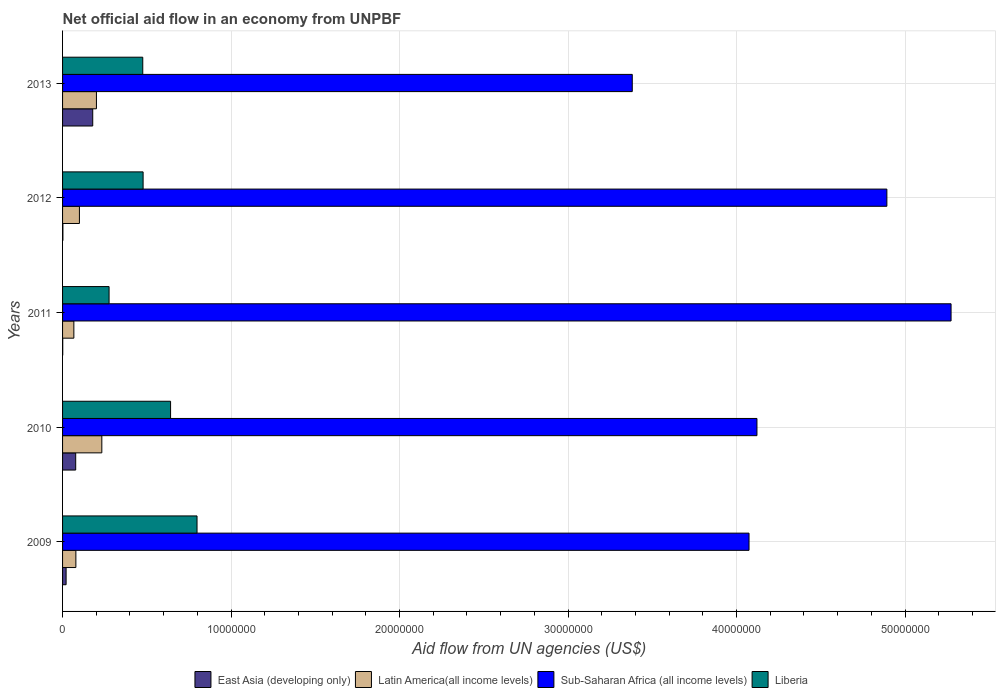How many different coloured bars are there?
Offer a very short reply. 4. How many groups of bars are there?
Your answer should be very brief. 5. Are the number of bars on each tick of the Y-axis equal?
Provide a succinct answer. Yes. How many bars are there on the 1st tick from the bottom?
Offer a very short reply. 4. What is the net official aid flow in East Asia (developing only) in 2011?
Your response must be concise. 10000. Across all years, what is the maximum net official aid flow in East Asia (developing only)?
Keep it short and to the point. 1.79e+06. Across all years, what is the minimum net official aid flow in Liberia?
Ensure brevity in your answer.  2.76e+06. In which year was the net official aid flow in East Asia (developing only) maximum?
Provide a short and direct response. 2013. In which year was the net official aid flow in Liberia minimum?
Your response must be concise. 2011. What is the total net official aid flow in East Asia (developing only) in the graph?
Ensure brevity in your answer.  2.81e+06. What is the difference between the net official aid flow in Sub-Saharan Africa (all income levels) in 2010 and that in 2011?
Ensure brevity in your answer.  -1.15e+07. What is the difference between the net official aid flow in Liberia in 2010 and the net official aid flow in Latin America(all income levels) in 2011?
Make the answer very short. 5.74e+06. What is the average net official aid flow in Liberia per year?
Offer a very short reply. 5.34e+06. In the year 2013, what is the difference between the net official aid flow in East Asia (developing only) and net official aid flow in Sub-Saharan Africa (all income levels)?
Your response must be concise. -3.20e+07. In how many years, is the net official aid flow in Latin America(all income levels) greater than 28000000 US$?
Offer a terse response. 0. What is the ratio of the net official aid flow in Sub-Saharan Africa (all income levels) in 2011 to that in 2013?
Your response must be concise. 1.56. Is the net official aid flow in Latin America(all income levels) in 2010 less than that in 2013?
Keep it short and to the point. No. Is the difference between the net official aid flow in East Asia (developing only) in 2010 and 2012 greater than the difference between the net official aid flow in Sub-Saharan Africa (all income levels) in 2010 and 2012?
Your answer should be very brief. Yes. What is the difference between the highest and the second highest net official aid flow in Liberia?
Your answer should be very brief. 1.57e+06. What is the difference between the highest and the lowest net official aid flow in Latin America(all income levels)?
Give a very brief answer. 1.66e+06. In how many years, is the net official aid flow in East Asia (developing only) greater than the average net official aid flow in East Asia (developing only) taken over all years?
Your response must be concise. 2. What does the 3rd bar from the top in 2009 represents?
Your answer should be compact. Latin America(all income levels). What does the 1st bar from the bottom in 2011 represents?
Offer a terse response. East Asia (developing only). How many bars are there?
Provide a short and direct response. 20. Are the values on the major ticks of X-axis written in scientific E-notation?
Give a very brief answer. No. Does the graph contain any zero values?
Ensure brevity in your answer.  No. Where does the legend appear in the graph?
Make the answer very short. Bottom center. How are the legend labels stacked?
Your answer should be compact. Horizontal. What is the title of the graph?
Provide a short and direct response. Net official aid flow in an economy from UNPBF. Does "Namibia" appear as one of the legend labels in the graph?
Ensure brevity in your answer.  No. What is the label or title of the X-axis?
Provide a short and direct response. Aid flow from UN agencies (US$). What is the label or title of the Y-axis?
Give a very brief answer. Years. What is the Aid flow from UN agencies (US$) of Latin America(all income levels) in 2009?
Keep it short and to the point. 7.90e+05. What is the Aid flow from UN agencies (US$) of Sub-Saharan Africa (all income levels) in 2009?
Ensure brevity in your answer.  4.07e+07. What is the Aid flow from UN agencies (US$) of Liberia in 2009?
Your answer should be very brief. 7.98e+06. What is the Aid flow from UN agencies (US$) in East Asia (developing only) in 2010?
Provide a succinct answer. 7.80e+05. What is the Aid flow from UN agencies (US$) of Latin America(all income levels) in 2010?
Provide a short and direct response. 2.33e+06. What is the Aid flow from UN agencies (US$) in Sub-Saharan Africa (all income levels) in 2010?
Your answer should be very brief. 4.12e+07. What is the Aid flow from UN agencies (US$) in Liberia in 2010?
Your answer should be very brief. 6.41e+06. What is the Aid flow from UN agencies (US$) in Latin America(all income levels) in 2011?
Offer a very short reply. 6.70e+05. What is the Aid flow from UN agencies (US$) in Sub-Saharan Africa (all income levels) in 2011?
Make the answer very short. 5.27e+07. What is the Aid flow from UN agencies (US$) of Liberia in 2011?
Offer a very short reply. 2.76e+06. What is the Aid flow from UN agencies (US$) in East Asia (developing only) in 2012?
Your answer should be very brief. 2.00e+04. What is the Aid flow from UN agencies (US$) in Latin America(all income levels) in 2012?
Offer a terse response. 1.00e+06. What is the Aid flow from UN agencies (US$) of Sub-Saharan Africa (all income levels) in 2012?
Ensure brevity in your answer.  4.89e+07. What is the Aid flow from UN agencies (US$) of Liberia in 2012?
Your answer should be very brief. 4.78e+06. What is the Aid flow from UN agencies (US$) in East Asia (developing only) in 2013?
Ensure brevity in your answer.  1.79e+06. What is the Aid flow from UN agencies (US$) in Latin America(all income levels) in 2013?
Your response must be concise. 2.01e+06. What is the Aid flow from UN agencies (US$) in Sub-Saharan Africa (all income levels) in 2013?
Ensure brevity in your answer.  3.38e+07. What is the Aid flow from UN agencies (US$) in Liberia in 2013?
Your answer should be very brief. 4.76e+06. Across all years, what is the maximum Aid flow from UN agencies (US$) in East Asia (developing only)?
Provide a short and direct response. 1.79e+06. Across all years, what is the maximum Aid flow from UN agencies (US$) of Latin America(all income levels)?
Your answer should be very brief. 2.33e+06. Across all years, what is the maximum Aid flow from UN agencies (US$) of Sub-Saharan Africa (all income levels)?
Your answer should be very brief. 5.27e+07. Across all years, what is the maximum Aid flow from UN agencies (US$) of Liberia?
Ensure brevity in your answer.  7.98e+06. Across all years, what is the minimum Aid flow from UN agencies (US$) in Latin America(all income levels)?
Your answer should be very brief. 6.70e+05. Across all years, what is the minimum Aid flow from UN agencies (US$) in Sub-Saharan Africa (all income levels)?
Provide a short and direct response. 3.38e+07. Across all years, what is the minimum Aid flow from UN agencies (US$) in Liberia?
Give a very brief answer. 2.76e+06. What is the total Aid flow from UN agencies (US$) of East Asia (developing only) in the graph?
Your response must be concise. 2.81e+06. What is the total Aid flow from UN agencies (US$) of Latin America(all income levels) in the graph?
Keep it short and to the point. 6.80e+06. What is the total Aid flow from UN agencies (US$) of Sub-Saharan Africa (all income levels) in the graph?
Offer a very short reply. 2.17e+08. What is the total Aid flow from UN agencies (US$) of Liberia in the graph?
Give a very brief answer. 2.67e+07. What is the difference between the Aid flow from UN agencies (US$) of East Asia (developing only) in 2009 and that in 2010?
Provide a succinct answer. -5.70e+05. What is the difference between the Aid flow from UN agencies (US$) in Latin America(all income levels) in 2009 and that in 2010?
Your answer should be very brief. -1.54e+06. What is the difference between the Aid flow from UN agencies (US$) of Sub-Saharan Africa (all income levels) in 2009 and that in 2010?
Keep it short and to the point. -4.70e+05. What is the difference between the Aid flow from UN agencies (US$) of Liberia in 2009 and that in 2010?
Offer a terse response. 1.57e+06. What is the difference between the Aid flow from UN agencies (US$) in Sub-Saharan Africa (all income levels) in 2009 and that in 2011?
Offer a terse response. -1.20e+07. What is the difference between the Aid flow from UN agencies (US$) of Liberia in 2009 and that in 2011?
Offer a terse response. 5.22e+06. What is the difference between the Aid flow from UN agencies (US$) of Sub-Saharan Africa (all income levels) in 2009 and that in 2012?
Give a very brief answer. -8.18e+06. What is the difference between the Aid flow from UN agencies (US$) in Liberia in 2009 and that in 2012?
Keep it short and to the point. 3.20e+06. What is the difference between the Aid flow from UN agencies (US$) of East Asia (developing only) in 2009 and that in 2013?
Make the answer very short. -1.58e+06. What is the difference between the Aid flow from UN agencies (US$) of Latin America(all income levels) in 2009 and that in 2013?
Ensure brevity in your answer.  -1.22e+06. What is the difference between the Aid flow from UN agencies (US$) in Sub-Saharan Africa (all income levels) in 2009 and that in 2013?
Provide a short and direct response. 6.93e+06. What is the difference between the Aid flow from UN agencies (US$) in Liberia in 2009 and that in 2013?
Give a very brief answer. 3.22e+06. What is the difference between the Aid flow from UN agencies (US$) in East Asia (developing only) in 2010 and that in 2011?
Provide a succinct answer. 7.70e+05. What is the difference between the Aid flow from UN agencies (US$) of Latin America(all income levels) in 2010 and that in 2011?
Provide a short and direct response. 1.66e+06. What is the difference between the Aid flow from UN agencies (US$) of Sub-Saharan Africa (all income levels) in 2010 and that in 2011?
Make the answer very short. -1.15e+07. What is the difference between the Aid flow from UN agencies (US$) of Liberia in 2010 and that in 2011?
Give a very brief answer. 3.65e+06. What is the difference between the Aid flow from UN agencies (US$) in East Asia (developing only) in 2010 and that in 2012?
Your answer should be very brief. 7.60e+05. What is the difference between the Aid flow from UN agencies (US$) in Latin America(all income levels) in 2010 and that in 2012?
Keep it short and to the point. 1.33e+06. What is the difference between the Aid flow from UN agencies (US$) of Sub-Saharan Africa (all income levels) in 2010 and that in 2012?
Provide a succinct answer. -7.71e+06. What is the difference between the Aid flow from UN agencies (US$) in Liberia in 2010 and that in 2012?
Your answer should be very brief. 1.63e+06. What is the difference between the Aid flow from UN agencies (US$) in East Asia (developing only) in 2010 and that in 2013?
Make the answer very short. -1.01e+06. What is the difference between the Aid flow from UN agencies (US$) of Latin America(all income levels) in 2010 and that in 2013?
Provide a short and direct response. 3.20e+05. What is the difference between the Aid flow from UN agencies (US$) of Sub-Saharan Africa (all income levels) in 2010 and that in 2013?
Your answer should be very brief. 7.40e+06. What is the difference between the Aid flow from UN agencies (US$) in Liberia in 2010 and that in 2013?
Ensure brevity in your answer.  1.65e+06. What is the difference between the Aid flow from UN agencies (US$) in East Asia (developing only) in 2011 and that in 2012?
Ensure brevity in your answer.  -10000. What is the difference between the Aid flow from UN agencies (US$) in Latin America(all income levels) in 2011 and that in 2012?
Keep it short and to the point. -3.30e+05. What is the difference between the Aid flow from UN agencies (US$) of Sub-Saharan Africa (all income levels) in 2011 and that in 2012?
Give a very brief answer. 3.81e+06. What is the difference between the Aid flow from UN agencies (US$) in Liberia in 2011 and that in 2012?
Your answer should be very brief. -2.02e+06. What is the difference between the Aid flow from UN agencies (US$) of East Asia (developing only) in 2011 and that in 2013?
Offer a very short reply. -1.78e+06. What is the difference between the Aid flow from UN agencies (US$) of Latin America(all income levels) in 2011 and that in 2013?
Keep it short and to the point. -1.34e+06. What is the difference between the Aid flow from UN agencies (US$) in Sub-Saharan Africa (all income levels) in 2011 and that in 2013?
Give a very brief answer. 1.89e+07. What is the difference between the Aid flow from UN agencies (US$) of East Asia (developing only) in 2012 and that in 2013?
Give a very brief answer. -1.77e+06. What is the difference between the Aid flow from UN agencies (US$) of Latin America(all income levels) in 2012 and that in 2013?
Make the answer very short. -1.01e+06. What is the difference between the Aid flow from UN agencies (US$) of Sub-Saharan Africa (all income levels) in 2012 and that in 2013?
Make the answer very short. 1.51e+07. What is the difference between the Aid flow from UN agencies (US$) of Liberia in 2012 and that in 2013?
Offer a very short reply. 2.00e+04. What is the difference between the Aid flow from UN agencies (US$) of East Asia (developing only) in 2009 and the Aid flow from UN agencies (US$) of Latin America(all income levels) in 2010?
Your answer should be very brief. -2.12e+06. What is the difference between the Aid flow from UN agencies (US$) in East Asia (developing only) in 2009 and the Aid flow from UN agencies (US$) in Sub-Saharan Africa (all income levels) in 2010?
Keep it short and to the point. -4.10e+07. What is the difference between the Aid flow from UN agencies (US$) in East Asia (developing only) in 2009 and the Aid flow from UN agencies (US$) in Liberia in 2010?
Your answer should be very brief. -6.20e+06. What is the difference between the Aid flow from UN agencies (US$) of Latin America(all income levels) in 2009 and the Aid flow from UN agencies (US$) of Sub-Saharan Africa (all income levels) in 2010?
Your response must be concise. -4.04e+07. What is the difference between the Aid flow from UN agencies (US$) of Latin America(all income levels) in 2009 and the Aid flow from UN agencies (US$) of Liberia in 2010?
Offer a terse response. -5.62e+06. What is the difference between the Aid flow from UN agencies (US$) of Sub-Saharan Africa (all income levels) in 2009 and the Aid flow from UN agencies (US$) of Liberia in 2010?
Give a very brief answer. 3.43e+07. What is the difference between the Aid flow from UN agencies (US$) in East Asia (developing only) in 2009 and the Aid flow from UN agencies (US$) in Latin America(all income levels) in 2011?
Provide a succinct answer. -4.60e+05. What is the difference between the Aid flow from UN agencies (US$) in East Asia (developing only) in 2009 and the Aid flow from UN agencies (US$) in Sub-Saharan Africa (all income levels) in 2011?
Give a very brief answer. -5.25e+07. What is the difference between the Aid flow from UN agencies (US$) of East Asia (developing only) in 2009 and the Aid flow from UN agencies (US$) of Liberia in 2011?
Offer a very short reply. -2.55e+06. What is the difference between the Aid flow from UN agencies (US$) of Latin America(all income levels) in 2009 and the Aid flow from UN agencies (US$) of Sub-Saharan Africa (all income levels) in 2011?
Offer a terse response. -5.19e+07. What is the difference between the Aid flow from UN agencies (US$) in Latin America(all income levels) in 2009 and the Aid flow from UN agencies (US$) in Liberia in 2011?
Make the answer very short. -1.97e+06. What is the difference between the Aid flow from UN agencies (US$) of Sub-Saharan Africa (all income levels) in 2009 and the Aid flow from UN agencies (US$) of Liberia in 2011?
Give a very brief answer. 3.80e+07. What is the difference between the Aid flow from UN agencies (US$) in East Asia (developing only) in 2009 and the Aid flow from UN agencies (US$) in Latin America(all income levels) in 2012?
Provide a succinct answer. -7.90e+05. What is the difference between the Aid flow from UN agencies (US$) of East Asia (developing only) in 2009 and the Aid flow from UN agencies (US$) of Sub-Saharan Africa (all income levels) in 2012?
Keep it short and to the point. -4.87e+07. What is the difference between the Aid flow from UN agencies (US$) of East Asia (developing only) in 2009 and the Aid flow from UN agencies (US$) of Liberia in 2012?
Offer a very short reply. -4.57e+06. What is the difference between the Aid flow from UN agencies (US$) of Latin America(all income levels) in 2009 and the Aid flow from UN agencies (US$) of Sub-Saharan Africa (all income levels) in 2012?
Keep it short and to the point. -4.81e+07. What is the difference between the Aid flow from UN agencies (US$) of Latin America(all income levels) in 2009 and the Aid flow from UN agencies (US$) of Liberia in 2012?
Give a very brief answer. -3.99e+06. What is the difference between the Aid flow from UN agencies (US$) of Sub-Saharan Africa (all income levels) in 2009 and the Aid flow from UN agencies (US$) of Liberia in 2012?
Ensure brevity in your answer.  3.60e+07. What is the difference between the Aid flow from UN agencies (US$) of East Asia (developing only) in 2009 and the Aid flow from UN agencies (US$) of Latin America(all income levels) in 2013?
Provide a short and direct response. -1.80e+06. What is the difference between the Aid flow from UN agencies (US$) of East Asia (developing only) in 2009 and the Aid flow from UN agencies (US$) of Sub-Saharan Africa (all income levels) in 2013?
Your response must be concise. -3.36e+07. What is the difference between the Aid flow from UN agencies (US$) of East Asia (developing only) in 2009 and the Aid flow from UN agencies (US$) of Liberia in 2013?
Offer a terse response. -4.55e+06. What is the difference between the Aid flow from UN agencies (US$) of Latin America(all income levels) in 2009 and the Aid flow from UN agencies (US$) of Sub-Saharan Africa (all income levels) in 2013?
Your response must be concise. -3.30e+07. What is the difference between the Aid flow from UN agencies (US$) in Latin America(all income levels) in 2009 and the Aid flow from UN agencies (US$) in Liberia in 2013?
Provide a short and direct response. -3.97e+06. What is the difference between the Aid flow from UN agencies (US$) in Sub-Saharan Africa (all income levels) in 2009 and the Aid flow from UN agencies (US$) in Liberia in 2013?
Keep it short and to the point. 3.60e+07. What is the difference between the Aid flow from UN agencies (US$) of East Asia (developing only) in 2010 and the Aid flow from UN agencies (US$) of Latin America(all income levels) in 2011?
Offer a very short reply. 1.10e+05. What is the difference between the Aid flow from UN agencies (US$) of East Asia (developing only) in 2010 and the Aid flow from UN agencies (US$) of Sub-Saharan Africa (all income levels) in 2011?
Your answer should be very brief. -5.20e+07. What is the difference between the Aid flow from UN agencies (US$) in East Asia (developing only) in 2010 and the Aid flow from UN agencies (US$) in Liberia in 2011?
Ensure brevity in your answer.  -1.98e+06. What is the difference between the Aid flow from UN agencies (US$) of Latin America(all income levels) in 2010 and the Aid flow from UN agencies (US$) of Sub-Saharan Africa (all income levels) in 2011?
Your answer should be compact. -5.04e+07. What is the difference between the Aid flow from UN agencies (US$) of Latin America(all income levels) in 2010 and the Aid flow from UN agencies (US$) of Liberia in 2011?
Make the answer very short. -4.30e+05. What is the difference between the Aid flow from UN agencies (US$) of Sub-Saharan Africa (all income levels) in 2010 and the Aid flow from UN agencies (US$) of Liberia in 2011?
Provide a short and direct response. 3.84e+07. What is the difference between the Aid flow from UN agencies (US$) in East Asia (developing only) in 2010 and the Aid flow from UN agencies (US$) in Latin America(all income levels) in 2012?
Provide a succinct answer. -2.20e+05. What is the difference between the Aid flow from UN agencies (US$) in East Asia (developing only) in 2010 and the Aid flow from UN agencies (US$) in Sub-Saharan Africa (all income levels) in 2012?
Offer a terse response. -4.81e+07. What is the difference between the Aid flow from UN agencies (US$) of East Asia (developing only) in 2010 and the Aid flow from UN agencies (US$) of Liberia in 2012?
Make the answer very short. -4.00e+06. What is the difference between the Aid flow from UN agencies (US$) in Latin America(all income levels) in 2010 and the Aid flow from UN agencies (US$) in Sub-Saharan Africa (all income levels) in 2012?
Give a very brief answer. -4.66e+07. What is the difference between the Aid flow from UN agencies (US$) of Latin America(all income levels) in 2010 and the Aid flow from UN agencies (US$) of Liberia in 2012?
Offer a terse response. -2.45e+06. What is the difference between the Aid flow from UN agencies (US$) of Sub-Saharan Africa (all income levels) in 2010 and the Aid flow from UN agencies (US$) of Liberia in 2012?
Give a very brief answer. 3.64e+07. What is the difference between the Aid flow from UN agencies (US$) of East Asia (developing only) in 2010 and the Aid flow from UN agencies (US$) of Latin America(all income levels) in 2013?
Offer a terse response. -1.23e+06. What is the difference between the Aid flow from UN agencies (US$) of East Asia (developing only) in 2010 and the Aid flow from UN agencies (US$) of Sub-Saharan Africa (all income levels) in 2013?
Offer a terse response. -3.30e+07. What is the difference between the Aid flow from UN agencies (US$) of East Asia (developing only) in 2010 and the Aid flow from UN agencies (US$) of Liberia in 2013?
Ensure brevity in your answer.  -3.98e+06. What is the difference between the Aid flow from UN agencies (US$) in Latin America(all income levels) in 2010 and the Aid flow from UN agencies (US$) in Sub-Saharan Africa (all income levels) in 2013?
Your answer should be very brief. -3.15e+07. What is the difference between the Aid flow from UN agencies (US$) of Latin America(all income levels) in 2010 and the Aid flow from UN agencies (US$) of Liberia in 2013?
Your answer should be compact. -2.43e+06. What is the difference between the Aid flow from UN agencies (US$) in Sub-Saharan Africa (all income levels) in 2010 and the Aid flow from UN agencies (US$) in Liberia in 2013?
Provide a succinct answer. 3.64e+07. What is the difference between the Aid flow from UN agencies (US$) in East Asia (developing only) in 2011 and the Aid flow from UN agencies (US$) in Latin America(all income levels) in 2012?
Provide a short and direct response. -9.90e+05. What is the difference between the Aid flow from UN agencies (US$) in East Asia (developing only) in 2011 and the Aid flow from UN agencies (US$) in Sub-Saharan Africa (all income levels) in 2012?
Your answer should be compact. -4.89e+07. What is the difference between the Aid flow from UN agencies (US$) in East Asia (developing only) in 2011 and the Aid flow from UN agencies (US$) in Liberia in 2012?
Offer a very short reply. -4.77e+06. What is the difference between the Aid flow from UN agencies (US$) in Latin America(all income levels) in 2011 and the Aid flow from UN agencies (US$) in Sub-Saharan Africa (all income levels) in 2012?
Offer a very short reply. -4.82e+07. What is the difference between the Aid flow from UN agencies (US$) in Latin America(all income levels) in 2011 and the Aid flow from UN agencies (US$) in Liberia in 2012?
Make the answer very short. -4.11e+06. What is the difference between the Aid flow from UN agencies (US$) in Sub-Saharan Africa (all income levels) in 2011 and the Aid flow from UN agencies (US$) in Liberia in 2012?
Give a very brief answer. 4.80e+07. What is the difference between the Aid flow from UN agencies (US$) of East Asia (developing only) in 2011 and the Aid flow from UN agencies (US$) of Sub-Saharan Africa (all income levels) in 2013?
Keep it short and to the point. -3.38e+07. What is the difference between the Aid flow from UN agencies (US$) of East Asia (developing only) in 2011 and the Aid flow from UN agencies (US$) of Liberia in 2013?
Provide a succinct answer. -4.75e+06. What is the difference between the Aid flow from UN agencies (US$) of Latin America(all income levels) in 2011 and the Aid flow from UN agencies (US$) of Sub-Saharan Africa (all income levels) in 2013?
Provide a short and direct response. -3.31e+07. What is the difference between the Aid flow from UN agencies (US$) in Latin America(all income levels) in 2011 and the Aid flow from UN agencies (US$) in Liberia in 2013?
Keep it short and to the point. -4.09e+06. What is the difference between the Aid flow from UN agencies (US$) in Sub-Saharan Africa (all income levels) in 2011 and the Aid flow from UN agencies (US$) in Liberia in 2013?
Provide a short and direct response. 4.80e+07. What is the difference between the Aid flow from UN agencies (US$) of East Asia (developing only) in 2012 and the Aid flow from UN agencies (US$) of Latin America(all income levels) in 2013?
Keep it short and to the point. -1.99e+06. What is the difference between the Aid flow from UN agencies (US$) of East Asia (developing only) in 2012 and the Aid flow from UN agencies (US$) of Sub-Saharan Africa (all income levels) in 2013?
Your answer should be very brief. -3.38e+07. What is the difference between the Aid flow from UN agencies (US$) of East Asia (developing only) in 2012 and the Aid flow from UN agencies (US$) of Liberia in 2013?
Offer a terse response. -4.74e+06. What is the difference between the Aid flow from UN agencies (US$) in Latin America(all income levels) in 2012 and the Aid flow from UN agencies (US$) in Sub-Saharan Africa (all income levels) in 2013?
Your response must be concise. -3.28e+07. What is the difference between the Aid flow from UN agencies (US$) of Latin America(all income levels) in 2012 and the Aid flow from UN agencies (US$) of Liberia in 2013?
Offer a terse response. -3.76e+06. What is the difference between the Aid flow from UN agencies (US$) of Sub-Saharan Africa (all income levels) in 2012 and the Aid flow from UN agencies (US$) of Liberia in 2013?
Give a very brief answer. 4.42e+07. What is the average Aid flow from UN agencies (US$) of East Asia (developing only) per year?
Ensure brevity in your answer.  5.62e+05. What is the average Aid flow from UN agencies (US$) of Latin America(all income levels) per year?
Make the answer very short. 1.36e+06. What is the average Aid flow from UN agencies (US$) in Sub-Saharan Africa (all income levels) per year?
Your answer should be very brief. 4.35e+07. What is the average Aid flow from UN agencies (US$) in Liberia per year?
Offer a terse response. 5.34e+06. In the year 2009, what is the difference between the Aid flow from UN agencies (US$) in East Asia (developing only) and Aid flow from UN agencies (US$) in Latin America(all income levels)?
Give a very brief answer. -5.80e+05. In the year 2009, what is the difference between the Aid flow from UN agencies (US$) of East Asia (developing only) and Aid flow from UN agencies (US$) of Sub-Saharan Africa (all income levels)?
Make the answer very short. -4.05e+07. In the year 2009, what is the difference between the Aid flow from UN agencies (US$) in East Asia (developing only) and Aid flow from UN agencies (US$) in Liberia?
Your answer should be compact. -7.77e+06. In the year 2009, what is the difference between the Aid flow from UN agencies (US$) of Latin America(all income levels) and Aid flow from UN agencies (US$) of Sub-Saharan Africa (all income levels)?
Offer a terse response. -4.00e+07. In the year 2009, what is the difference between the Aid flow from UN agencies (US$) of Latin America(all income levels) and Aid flow from UN agencies (US$) of Liberia?
Offer a terse response. -7.19e+06. In the year 2009, what is the difference between the Aid flow from UN agencies (US$) of Sub-Saharan Africa (all income levels) and Aid flow from UN agencies (US$) of Liberia?
Your answer should be compact. 3.28e+07. In the year 2010, what is the difference between the Aid flow from UN agencies (US$) of East Asia (developing only) and Aid flow from UN agencies (US$) of Latin America(all income levels)?
Provide a succinct answer. -1.55e+06. In the year 2010, what is the difference between the Aid flow from UN agencies (US$) in East Asia (developing only) and Aid flow from UN agencies (US$) in Sub-Saharan Africa (all income levels)?
Provide a succinct answer. -4.04e+07. In the year 2010, what is the difference between the Aid flow from UN agencies (US$) of East Asia (developing only) and Aid flow from UN agencies (US$) of Liberia?
Provide a short and direct response. -5.63e+06. In the year 2010, what is the difference between the Aid flow from UN agencies (US$) in Latin America(all income levels) and Aid flow from UN agencies (US$) in Sub-Saharan Africa (all income levels)?
Provide a succinct answer. -3.89e+07. In the year 2010, what is the difference between the Aid flow from UN agencies (US$) in Latin America(all income levels) and Aid flow from UN agencies (US$) in Liberia?
Offer a terse response. -4.08e+06. In the year 2010, what is the difference between the Aid flow from UN agencies (US$) of Sub-Saharan Africa (all income levels) and Aid flow from UN agencies (US$) of Liberia?
Provide a short and direct response. 3.48e+07. In the year 2011, what is the difference between the Aid flow from UN agencies (US$) of East Asia (developing only) and Aid flow from UN agencies (US$) of Latin America(all income levels)?
Provide a succinct answer. -6.60e+05. In the year 2011, what is the difference between the Aid flow from UN agencies (US$) in East Asia (developing only) and Aid flow from UN agencies (US$) in Sub-Saharan Africa (all income levels)?
Give a very brief answer. -5.27e+07. In the year 2011, what is the difference between the Aid flow from UN agencies (US$) of East Asia (developing only) and Aid flow from UN agencies (US$) of Liberia?
Make the answer very short. -2.75e+06. In the year 2011, what is the difference between the Aid flow from UN agencies (US$) in Latin America(all income levels) and Aid flow from UN agencies (US$) in Sub-Saharan Africa (all income levels)?
Your response must be concise. -5.21e+07. In the year 2011, what is the difference between the Aid flow from UN agencies (US$) of Latin America(all income levels) and Aid flow from UN agencies (US$) of Liberia?
Your answer should be compact. -2.09e+06. In the year 2011, what is the difference between the Aid flow from UN agencies (US$) of Sub-Saharan Africa (all income levels) and Aid flow from UN agencies (US$) of Liberia?
Give a very brief answer. 5.00e+07. In the year 2012, what is the difference between the Aid flow from UN agencies (US$) in East Asia (developing only) and Aid flow from UN agencies (US$) in Latin America(all income levels)?
Provide a short and direct response. -9.80e+05. In the year 2012, what is the difference between the Aid flow from UN agencies (US$) in East Asia (developing only) and Aid flow from UN agencies (US$) in Sub-Saharan Africa (all income levels)?
Provide a short and direct response. -4.89e+07. In the year 2012, what is the difference between the Aid flow from UN agencies (US$) of East Asia (developing only) and Aid flow from UN agencies (US$) of Liberia?
Offer a very short reply. -4.76e+06. In the year 2012, what is the difference between the Aid flow from UN agencies (US$) of Latin America(all income levels) and Aid flow from UN agencies (US$) of Sub-Saharan Africa (all income levels)?
Offer a very short reply. -4.79e+07. In the year 2012, what is the difference between the Aid flow from UN agencies (US$) of Latin America(all income levels) and Aid flow from UN agencies (US$) of Liberia?
Provide a succinct answer. -3.78e+06. In the year 2012, what is the difference between the Aid flow from UN agencies (US$) in Sub-Saharan Africa (all income levels) and Aid flow from UN agencies (US$) in Liberia?
Your response must be concise. 4.41e+07. In the year 2013, what is the difference between the Aid flow from UN agencies (US$) of East Asia (developing only) and Aid flow from UN agencies (US$) of Sub-Saharan Africa (all income levels)?
Your answer should be compact. -3.20e+07. In the year 2013, what is the difference between the Aid flow from UN agencies (US$) in East Asia (developing only) and Aid flow from UN agencies (US$) in Liberia?
Make the answer very short. -2.97e+06. In the year 2013, what is the difference between the Aid flow from UN agencies (US$) in Latin America(all income levels) and Aid flow from UN agencies (US$) in Sub-Saharan Africa (all income levels)?
Your answer should be compact. -3.18e+07. In the year 2013, what is the difference between the Aid flow from UN agencies (US$) in Latin America(all income levels) and Aid flow from UN agencies (US$) in Liberia?
Ensure brevity in your answer.  -2.75e+06. In the year 2013, what is the difference between the Aid flow from UN agencies (US$) in Sub-Saharan Africa (all income levels) and Aid flow from UN agencies (US$) in Liberia?
Offer a very short reply. 2.90e+07. What is the ratio of the Aid flow from UN agencies (US$) of East Asia (developing only) in 2009 to that in 2010?
Provide a short and direct response. 0.27. What is the ratio of the Aid flow from UN agencies (US$) in Latin America(all income levels) in 2009 to that in 2010?
Your response must be concise. 0.34. What is the ratio of the Aid flow from UN agencies (US$) of Liberia in 2009 to that in 2010?
Ensure brevity in your answer.  1.24. What is the ratio of the Aid flow from UN agencies (US$) of East Asia (developing only) in 2009 to that in 2011?
Provide a succinct answer. 21. What is the ratio of the Aid flow from UN agencies (US$) of Latin America(all income levels) in 2009 to that in 2011?
Ensure brevity in your answer.  1.18. What is the ratio of the Aid flow from UN agencies (US$) of Sub-Saharan Africa (all income levels) in 2009 to that in 2011?
Offer a terse response. 0.77. What is the ratio of the Aid flow from UN agencies (US$) in Liberia in 2009 to that in 2011?
Give a very brief answer. 2.89. What is the ratio of the Aid flow from UN agencies (US$) in Latin America(all income levels) in 2009 to that in 2012?
Provide a succinct answer. 0.79. What is the ratio of the Aid flow from UN agencies (US$) in Sub-Saharan Africa (all income levels) in 2009 to that in 2012?
Offer a terse response. 0.83. What is the ratio of the Aid flow from UN agencies (US$) in Liberia in 2009 to that in 2012?
Provide a short and direct response. 1.67. What is the ratio of the Aid flow from UN agencies (US$) in East Asia (developing only) in 2009 to that in 2013?
Ensure brevity in your answer.  0.12. What is the ratio of the Aid flow from UN agencies (US$) of Latin America(all income levels) in 2009 to that in 2013?
Give a very brief answer. 0.39. What is the ratio of the Aid flow from UN agencies (US$) of Sub-Saharan Africa (all income levels) in 2009 to that in 2013?
Offer a very short reply. 1.21. What is the ratio of the Aid flow from UN agencies (US$) of Liberia in 2009 to that in 2013?
Ensure brevity in your answer.  1.68. What is the ratio of the Aid flow from UN agencies (US$) in Latin America(all income levels) in 2010 to that in 2011?
Provide a succinct answer. 3.48. What is the ratio of the Aid flow from UN agencies (US$) in Sub-Saharan Africa (all income levels) in 2010 to that in 2011?
Offer a very short reply. 0.78. What is the ratio of the Aid flow from UN agencies (US$) of Liberia in 2010 to that in 2011?
Your response must be concise. 2.32. What is the ratio of the Aid flow from UN agencies (US$) in Latin America(all income levels) in 2010 to that in 2012?
Offer a terse response. 2.33. What is the ratio of the Aid flow from UN agencies (US$) of Sub-Saharan Africa (all income levels) in 2010 to that in 2012?
Give a very brief answer. 0.84. What is the ratio of the Aid flow from UN agencies (US$) in Liberia in 2010 to that in 2012?
Your answer should be compact. 1.34. What is the ratio of the Aid flow from UN agencies (US$) in East Asia (developing only) in 2010 to that in 2013?
Offer a very short reply. 0.44. What is the ratio of the Aid flow from UN agencies (US$) of Latin America(all income levels) in 2010 to that in 2013?
Provide a short and direct response. 1.16. What is the ratio of the Aid flow from UN agencies (US$) in Sub-Saharan Africa (all income levels) in 2010 to that in 2013?
Make the answer very short. 1.22. What is the ratio of the Aid flow from UN agencies (US$) in Liberia in 2010 to that in 2013?
Your answer should be very brief. 1.35. What is the ratio of the Aid flow from UN agencies (US$) of East Asia (developing only) in 2011 to that in 2012?
Keep it short and to the point. 0.5. What is the ratio of the Aid flow from UN agencies (US$) in Latin America(all income levels) in 2011 to that in 2012?
Ensure brevity in your answer.  0.67. What is the ratio of the Aid flow from UN agencies (US$) in Sub-Saharan Africa (all income levels) in 2011 to that in 2012?
Ensure brevity in your answer.  1.08. What is the ratio of the Aid flow from UN agencies (US$) of Liberia in 2011 to that in 2012?
Provide a short and direct response. 0.58. What is the ratio of the Aid flow from UN agencies (US$) of East Asia (developing only) in 2011 to that in 2013?
Your response must be concise. 0.01. What is the ratio of the Aid flow from UN agencies (US$) in Latin America(all income levels) in 2011 to that in 2013?
Offer a very short reply. 0.33. What is the ratio of the Aid flow from UN agencies (US$) in Sub-Saharan Africa (all income levels) in 2011 to that in 2013?
Ensure brevity in your answer.  1.56. What is the ratio of the Aid flow from UN agencies (US$) in Liberia in 2011 to that in 2013?
Make the answer very short. 0.58. What is the ratio of the Aid flow from UN agencies (US$) of East Asia (developing only) in 2012 to that in 2013?
Your answer should be very brief. 0.01. What is the ratio of the Aid flow from UN agencies (US$) in Latin America(all income levels) in 2012 to that in 2013?
Give a very brief answer. 0.5. What is the ratio of the Aid flow from UN agencies (US$) of Sub-Saharan Africa (all income levels) in 2012 to that in 2013?
Keep it short and to the point. 1.45. What is the difference between the highest and the second highest Aid flow from UN agencies (US$) in East Asia (developing only)?
Offer a terse response. 1.01e+06. What is the difference between the highest and the second highest Aid flow from UN agencies (US$) in Latin America(all income levels)?
Offer a terse response. 3.20e+05. What is the difference between the highest and the second highest Aid flow from UN agencies (US$) of Sub-Saharan Africa (all income levels)?
Your answer should be very brief. 3.81e+06. What is the difference between the highest and the second highest Aid flow from UN agencies (US$) of Liberia?
Make the answer very short. 1.57e+06. What is the difference between the highest and the lowest Aid flow from UN agencies (US$) in East Asia (developing only)?
Ensure brevity in your answer.  1.78e+06. What is the difference between the highest and the lowest Aid flow from UN agencies (US$) in Latin America(all income levels)?
Ensure brevity in your answer.  1.66e+06. What is the difference between the highest and the lowest Aid flow from UN agencies (US$) of Sub-Saharan Africa (all income levels)?
Give a very brief answer. 1.89e+07. What is the difference between the highest and the lowest Aid flow from UN agencies (US$) of Liberia?
Keep it short and to the point. 5.22e+06. 